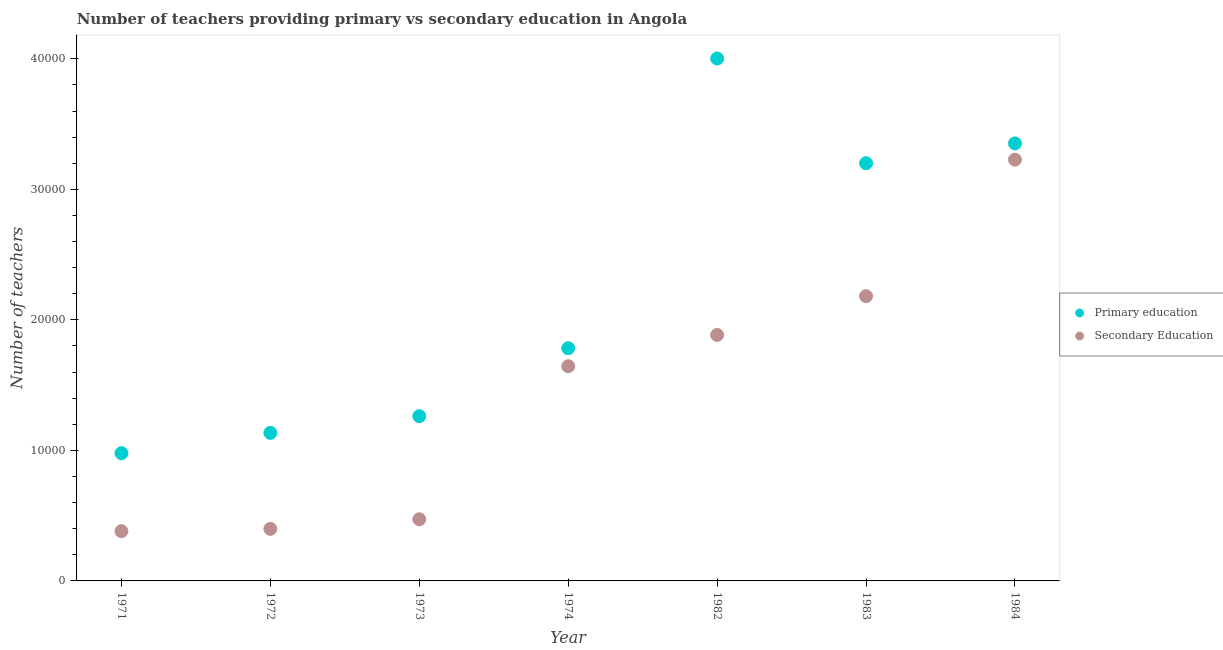How many different coloured dotlines are there?
Give a very brief answer. 2. Is the number of dotlines equal to the number of legend labels?
Ensure brevity in your answer.  Yes. What is the number of secondary teachers in 1983?
Your response must be concise. 2.18e+04. Across all years, what is the maximum number of secondary teachers?
Your answer should be compact. 3.23e+04. Across all years, what is the minimum number of primary teachers?
Ensure brevity in your answer.  9786. In which year was the number of primary teachers maximum?
Offer a terse response. 1982. In which year was the number of primary teachers minimum?
Provide a short and direct response. 1971. What is the total number of secondary teachers in the graph?
Your response must be concise. 1.02e+05. What is the difference between the number of primary teachers in 1973 and that in 1974?
Provide a succinct answer. -5209. What is the difference between the number of secondary teachers in 1982 and the number of primary teachers in 1971?
Provide a short and direct response. 9062. What is the average number of primary teachers per year?
Give a very brief answer. 2.24e+04. In the year 1983, what is the difference between the number of primary teachers and number of secondary teachers?
Offer a terse response. 1.02e+04. In how many years, is the number of secondary teachers greater than 38000?
Offer a terse response. 0. What is the ratio of the number of secondary teachers in 1971 to that in 1983?
Your response must be concise. 0.17. Is the number of primary teachers in 1973 less than that in 1974?
Offer a terse response. Yes. What is the difference between the highest and the second highest number of secondary teachers?
Provide a succinct answer. 1.05e+04. What is the difference between the highest and the lowest number of secondary teachers?
Give a very brief answer. 2.85e+04. In how many years, is the number of primary teachers greater than the average number of primary teachers taken over all years?
Provide a short and direct response. 3. Is the sum of the number of primary teachers in 1974 and 1984 greater than the maximum number of secondary teachers across all years?
Your response must be concise. Yes. Does the number of secondary teachers monotonically increase over the years?
Your answer should be very brief. Yes. How many dotlines are there?
Offer a very short reply. 2. Are the values on the major ticks of Y-axis written in scientific E-notation?
Your answer should be very brief. No. Where does the legend appear in the graph?
Your response must be concise. Center right. How many legend labels are there?
Your answer should be very brief. 2. How are the legend labels stacked?
Keep it short and to the point. Vertical. What is the title of the graph?
Keep it short and to the point. Number of teachers providing primary vs secondary education in Angola. What is the label or title of the Y-axis?
Provide a short and direct response. Number of teachers. What is the Number of teachers in Primary education in 1971?
Ensure brevity in your answer.  9786. What is the Number of teachers of Secondary Education in 1971?
Offer a very short reply. 3814. What is the Number of teachers in Primary education in 1972?
Ensure brevity in your answer.  1.13e+04. What is the Number of teachers of Secondary Education in 1972?
Ensure brevity in your answer.  3987. What is the Number of teachers in Primary education in 1973?
Your response must be concise. 1.26e+04. What is the Number of teachers of Secondary Education in 1973?
Give a very brief answer. 4723. What is the Number of teachers of Primary education in 1974?
Offer a very short reply. 1.78e+04. What is the Number of teachers of Secondary Education in 1974?
Give a very brief answer. 1.64e+04. What is the Number of teachers in Primary education in 1982?
Give a very brief answer. 4.00e+04. What is the Number of teachers in Secondary Education in 1982?
Provide a succinct answer. 1.88e+04. What is the Number of teachers in Primary education in 1983?
Offer a very short reply. 3.20e+04. What is the Number of teachers in Secondary Education in 1983?
Provide a short and direct response. 2.18e+04. What is the Number of teachers of Primary education in 1984?
Your response must be concise. 3.35e+04. What is the Number of teachers in Secondary Education in 1984?
Your answer should be compact. 3.23e+04. Across all years, what is the maximum Number of teachers of Primary education?
Give a very brief answer. 4.00e+04. Across all years, what is the maximum Number of teachers in Secondary Education?
Your answer should be compact. 3.23e+04. Across all years, what is the minimum Number of teachers of Primary education?
Your answer should be compact. 9786. Across all years, what is the minimum Number of teachers of Secondary Education?
Give a very brief answer. 3814. What is the total Number of teachers of Primary education in the graph?
Your response must be concise. 1.57e+05. What is the total Number of teachers in Secondary Education in the graph?
Ensure brevity in your answer.  1.02e+05. What is the difference between the Number of teachers of Primary education in 1971 and that in 1972?
Provide a succinct answer. -1557. What is the difference between the Number of teachers of Secondary Education in 1971 and that in 1972?
Your answer should be very brief. -173. What is the difference between the Number of teachers of Primary education in 1971 and that in 1973?
Your answer should be very brief. -2836. What is the difference between the Number of teachers in Secondary Education in 1971 and that in 1973?
Your answer should be very brief. -909. What is the difference between the Number of teachers in Primary education in 1971 and that in 1974?
Your response must be concise. -8045. What is the difference between the Number of teachers in Secondary Education in 1971 and that in 1974?
Make the answer very short. -1.26e+04. What is the difference between the Number of teachers of Primary education in 1971 and that in 1982?
Offer a terse response. -3.02e+04. What is the difference between the Number of teachers in Secondary Education in 1971 and that in 1982?
Provide a succinct answer. -1.50e+04. What is the difference between the Number of teachers of Primary education in 1971 and that in 1983?
Your response must be concise. -2.22e+04. What is the difference between the Number of teachers of Secondary Education in 1971 and that in 1983?
Provide a short and direct response. -1.80e+04. What is the difference between the Number of teachers of Primary education in 1971 and that in 1984?
Offer a terse response. -2.37e+04. What is the difference between the Number of teachers in Secondary Education in 1971 and that in 1984?
Offer a very short reply. -2.85e+04. What is the difference between the Number of teachers of Primary education in 1972 and that in 1973?
Provide a succinct answer. -1279. What is the difference between the Number of teachers in Secondary Education in 1972 and that in 1973?
Your answer should be compact. -736. What is the difference between the Number of teachers of Primary education in 1972 and that in 1974?
Provide a short and direct response. -6488. What is the difference between the Number of teachers in Secondary Education in 1972 and that in 1974?
Give a very brief answer. -1.25e+04. What is the difference between the Number of teachers of Primary education in 1972 and that in 1982?
Provide a short and direct response. -2.87e+04. What is the difference between the Number of teachers of Secondary Education in 1972 and that in 1982?
Provide a short and direct response. -1.49e+04. What is the difference between the Number of teachers in Primary education in 1972 and that in 1983?
Ensure brevity in your answer.  -2.07e+04. What is the difference between the Number of teachers of Secondary Education in 1972 and that in 1983?
Offer a very short reply. -1.78e+04. What is the difference between the Number of teachers in Primary education in 1972 and that in 1984?
Keep it short and to the point. -2.22e+04. What is the difference between the Number of teachers in Secondary Education in 1972 and that in 1984?
Make the answer very short. -2.83e+04. What is the difference between the Number of teachers in Primary education in 1973 and that in 1974?
Keep it short and to the point. -5209. What is the difference between the Number of teachers in Secondary Education in 1973 and that in 1974?
Provide a succinct answer. -1.17e+04. What is the difference between the Number of teachers in Primary education in 1973 and that in 1982?
Keep it short and to the point. -2.74e+04. What is the difference between the Number of teachers in Secondary Education in 1973 and that in 1982?
Make the answer very short. -1.41e+04. What is the difference between the Number of teachers of Primary education in 1973 and that in 1983?
Keep it short and to the point. -1.94e+04. What is the difference between the Number of teachers in Secondary Education in 1973 and that in 1983?
Make the answer very short. -1.71e+04. What is the difference between the Number of teachers of Primary education in 1973 and that in 1984?
Your response must be concise. -2.09e+04. What is the difference between the Number of teachers of Secondary Education in 1973 and that in 1984?
Provide a short and direct response. -2.76e+04. What is the difference between the Number of teachers of Primary education in 1974 and that in 1982?
Provide a succinct answer. -2.22e+04. What is the difference between the Number of teachers of Secondary Education in 1974 and that in 1982?
Ensure brevity in your answer.  -2401. What is the difference between the Number of teachers of Primary education in 1974 and that in 1983?
Offer a very short reply. -1.42e+04. What is the difference between the Number of teachers of Secondary Education in 1974 and that in 1983?
Offer a very short reply. -5371. What is the difference between the Number of teachers of Primary education in 1974 and that in 1984?
Your answer should be compact. -1.57e+04. What is the difference between the Number of teachers of Secondary Education in 1974 and that in 1984?
Provide a succinct answer. -1.58e+04. What is the difference between the Number of teachers of Primary education in 1982 and that in 1983?
Offer a terse response. 8023. What is the difference between the Number of teachers in Secondary Education in 1982 and that in 1983?
Ensure brevity in your answer.  -2970. What is the difference between the Number of teachers of Primary education in 1982 and that in 1984?
Give a very brief answer. 6506. What is the difference between the Number of teachers in Secondary Education in 1982 and that in 1984?
Offer a terse response. -1.34e+04. What is the difference between the Number of teachers of Primary education in 1983 and that in 1984?
Offer a very short reply. -1517. What is the difference between the Number of teachers of Secondary Education in 1983 and that in 1984?
Offer a terse response. -1.05e+04. What is the difference between the Number of teachers in Primary education in 1971 and the Number of teachers in Secondary Education in 1972?
Offer a very short reply. 5799. What is the difference between the Number of teachers of Primary education in 1971 and the Number of teachers of Secondary Education in 1973?
Offer a terse response. 5063. What is the difference between the Number of teachers of Primary education in 1971 and the Number of teachers of Secondary Education in 1974?
Your response must be concise. -6661. What is the difference between the Number of teachers in Primary education in 1971 and the Number of teachers in Secondary Education in 1982?
Provide a short and direct response. -9062. What is the difference between the Number of teachers of Primary education in 1971 and the Number of teachers of Secondary Education in 1983?
Your response must be concise. -1.20e+04. What is the difference between the Number of teachers in Primary education in 1971 and the Number of teachers in Secondary Education in 1984?
Your response must be concise. -2.25e+04. What is the difference between the Number of teachers in Primary education in 1972 and the Number of teachers in Secondary Education in 1973?
Offer a very short reply. 6620. What is the difference between the Number of teachers in Primary education in 1972 and the Number of teachers in Secondary Education in 1974?
Provide a succinct answer. -5104. What is the difference between the Number of teachers in Primary education in 1972 and the Number of teachers in Secondary Education in 1982?
Give a very brief answer. -7505. What is the difference between the Number of teachers in Primary education in 1972 and the Number of teachers in Secondary Education in 1983?
Make the answer very short. -1.05e+04. What is the difference between the Number of teachers in Primary education in 1972 and the Number of teachers in Secondary Education in 1984?
Offer a terse response. -2.09e+04. What is the difference between the Number of teachers in Primary education in 1973 and the Number of teachers in Secondary Education in 1974?
Offer a very short reply. -3825. What is the difference between the Number of teachers of Primary education in 1973 and the Number of teachers of Secondary Education in 1982?
Provide a short and direct response. -6226. What is the difference between the Number of teachers of Primary education in 1973 and the Number of teachers of Secondary Education in 1983?
Offer a very short reply. -9196. What is the difference between the Number of teachers of Primary education in 1973 and the Number of teachers of Secondary Education in 1984?
Provide a succinct answer. -1.97e+04. What is the difference between the Number of teachers in Primary education in 1974 and the Number of teachers in Secondary Education in 1982?
Provide a succinct answer. -1017. What is the difference between the Number of teachers in Primary education in 1974 and the Number of teachers in Secondary Education in 1983?
Give a very brief answer. -3987. What is the difference between the Number of teachers in Primary education in 1974 and the Number of teachers in Secondary Education in 1984?
Your response must be concise. -1.44e+04. What is the difference between the Number of teachers of Primary education in 1982 and the Number of teachers of Secondary Education in 1983?
Give a very brief answer. 1.82e+04. What is the difference between the Number of teachers of Primary education in 1982 and the Number of teachers of Secondary Education in 1984?
Offer a terse response. 7748. What is the difference between the Number of teachers of Primary education in 1983 and the Number of teachers of Secondary Education in 1984?
Keep it short and to the point. -275. What is the average Number of teachers of Primary education per year?
Provide a succinct answer. 2.24e+04. What is the average Number of teachers in Secondary Education per year?
Provide a short and direct response. 1.46e+04. In the year 1971, what is the difference between the Number of teachers of Primary education and Number of teachers of Secondary Education?
Provide a short and direct response. 5972. In the year 1972, what is the difference between the Number of teachers of Primary education and Number of teachers of Secondary Education?
Provide a short and direct response. 7356. In the year 1973, what is the difference between the Number of teachers of Primary education and Number of teachers of Secondary Education?
Offer a very short reply. 7899. In the year 1974, what is the difference between the Number of teachers in Primary education and Number of teachers in Secondary Education?
Give a very brief answer. 1384. In the year 1982, what is the difference between the Number of teachers in Primary education and Number of teachers in Secondary Education?
Your answer should be compact. 2.12e+04. In the year 1983, what is the difference between the Number of teachers in Primary education and Number of teachers in Secondary Education?
Provide a short and direct response. 1.02e+04. In the year 1984, what is the difference between the Number of teachers of Primary education and Number of teachers of Secondary Education?
Offer a terse response. 1242. What is the ratio of the Number of teachers of Primary education in 1971 to that in 1972?
Provide a succinct answer. 0.86. What is the ratio of the Number of teachers of Secondary Education in 1971 to that in 1972?
Ensure brevity in your answer.  0.96. What is the ratio of the Number of teachers in Primary education in 1971 to that in 1973?
Make the answer very short. 0.78. What is the ratio of the Number of teachers of Secondary Education in 1971 to that in 1973?
Ensure brevity in your answer.  0.81. What is the ratio of the Number of teachers in Primary education in 1971 to that in 1974?
Offer a very short reply. 0.55. What is the ratio of the Number of teachers of Secondary Education in 1971 to that in 1974?
Make the answer very short. 0.23. What is the ratio of the Number of teachers of Primary education in 1971 to that in 1982?
Give a very brief answer. 0.24. What is the ratio of the Number of teachers in Secondary Education in 1971 to that in 1982?
Give a very brief answer. 0.2. What is the ratio of the Number of teachers of Primary education in 1971 to that in 1983?
Provide a succinct answer. 0.31. What is the ratio of the Number of teachers in Secondary Education in 1971 to that in 1983?
Offer a terse response. 0.17. What is the ratio of the Number of teachers of Primary education in 1971 to that in 1984?
Your answer should be compact. 0.29. What is the ratio of the Number of teachers of Secondary Education in 1971 to that in 1984?
Keep it short and to the point. 0.12. What is the ratio of the Number of teachers in Primary education in 1972 to that in 1973?
Offer a very short reply. 0.9. What is the ratio of the Number of teachers in Secondary Education in 1972 to that in 1973?
Keep it short and to the point. 0.84. What is the ratio of the Number of teachers of Primary education in 1972 to that in 1974?
Provide a succinct answer. 0.64. What is the ratio of the Number of teachers of Secondary Education in 1972 to that in 1974?
Your answer should be very brief. 0.24. What is the ratio of the Number of teachers in Primary education in 1972 to that in 1982?
Offer a terse response. 0.28. What is the ratio of the Number of teachers in Secondary Education in 1972 to that in 1982?
Keep it short and to the point. 0.21. What is the ratio of the Number of teachers of Primary education in 1972 to that in 1983?
Provide a succinct answer. 0.35. What is the ratio of the Number of teachers in Secondary Education in 1972 to that in 1983?
Keep it short and to the point. 0.18. What is the ratio of the Number of teachers in Primary education in 1972 to that in 1984?
Make the answer very short. 0.34. What is the ratio of the Number of teachers in Secondary Education in 1972 to that in 1984?
Provide a short and direct response. 0.12. What is the ratio of the Number of teachers in Primary education in 1973 to that in 1974?
Give a very brief answer. 0.71. What is the ratio of the Number of teachers of Secondary Education in 1973 to that in 1974?
Your answer should be very brief. 0.29. What is the ratio of the Number of teachers in Primary education in 1973 to that in 1982?
Give a very brief answer. 0.32. What is the ratio of the Number of teachers in Secondary Education in 1973 to that in 1982?
Make the answer very short. 0.25. What is the ratio of the Number of teachers of Primary education in 1973 to that in 1983?
Give a very brief answer. 0.39. What is the ratio of the Number of teachers of Secondary Education in 1973 to that in 1983?
Give a very brief answer. 0.22. What is the ratio of the Number of teachers in Primary education in 1973 to that in 1984?
Provide a short and direct response. 0.38. What is the ratio of the Number of teachers in Secondary Education in 1973 to that in 1984?
Provide a short and direct response. 0.15. What is the ratio of the Number of teachers in Primary education in 1974 to that in 1982?
Give a very brief answer. 0.45. What is the ratio of the Number of teachers of Secondary Education in 1974 to that in 1982?
Your response must be concise. 0.87. What is the ratio of the Number of teachers of Primary education in 1974 to that in 1983?
Give a very brief answer. 0.56. What is the ratio of the Number of teachers in Secondary Education in 1974 to that in 1983?
Offer a terse response. 0.75. What is the ratio of the Number of teachers of Primary education in 1974 to that in 1984?
Ensure brevity in your answer.  0.53. What is the ratio of the Number of teachers in Secondary Education in 1974 to that in 1984?
Your answer should be compact. 0.51. What is the ratio of the Number of teachers in Primary education in 1982 to that in 1983?
Provide a succinct answer. 1.25. What is the ratio of the Number of teachers in Secondary Education in 1982 to that in 1983?
Provide a short and direct response. 0.86. What is the ratio of the Number of teachers in Primary education in 1982 to that in 1984?
Make the answer very short. 1.19. What is the ratio of the Number of teachers of Secondary Education in 1982 to that in 1984?
Ensure brevity in your answer.  0.58. What is the ratio of the Number of teachers of Primary education in 1983 to that in 1984?
Your answer should be compact. 0.95. What is the ratio of the Number of teachers in Secondary Education in 1983 to that in 1984?
Make the answer very short. 0.68. What is the difference between the highest and the second highest Number of teachers in Primary education?
Your answer should be very brief. 6506. What is the difference between the highest and the second highest Number of teachers of Secondary Education?
Provide a short and direct response. 1.05e+04. What is the difference between the highest and the lowest Number of teachers of Primary education?
Give a very brief answer. 3.02e+04. What is the difference between the highest and the lowest Number of teachers of Secondary Education?
Your answer should be compact. 2.85e+04. 